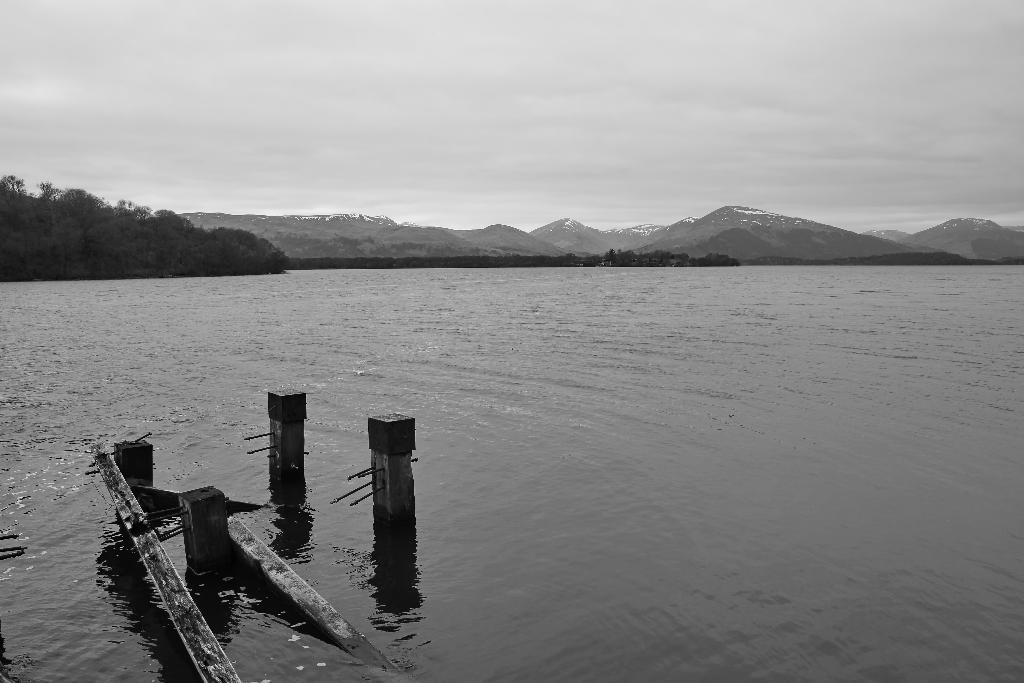Please provide a concise description of this image. This is a black and white picture, we can see there are some trees, poles, mountains and the water, which looks like a river, in the background we can see the sky. 